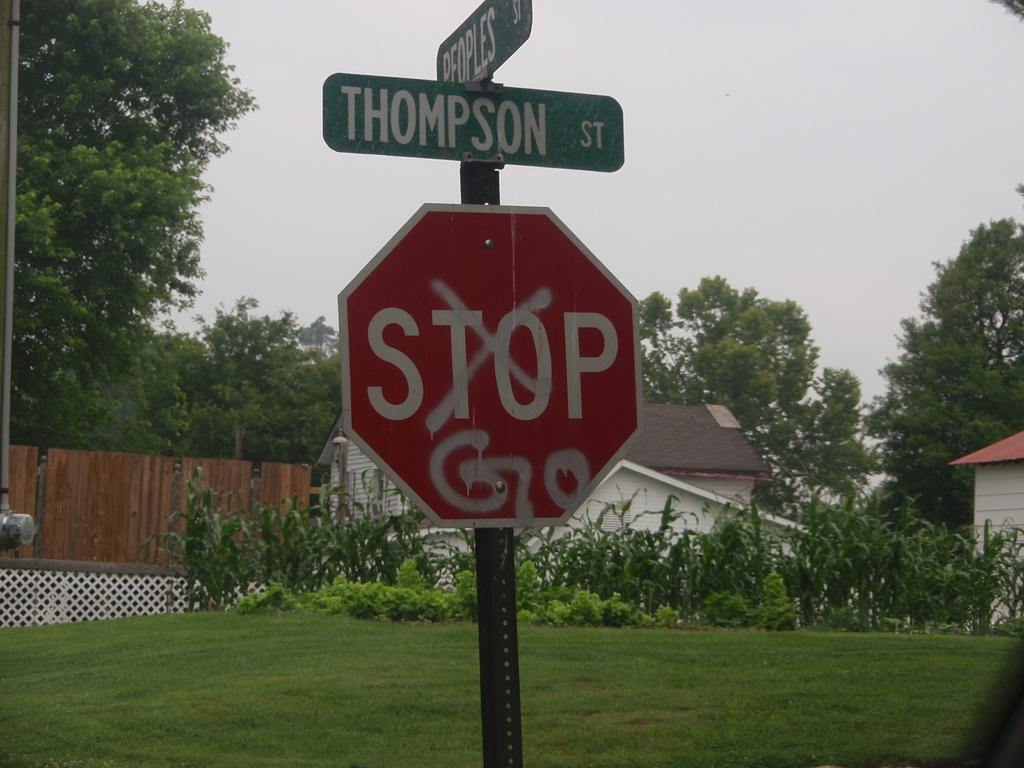<image>
Render a clear and concise summary of the photo. A stop sign at the intersection of Peoples Street and Thompson Street. 